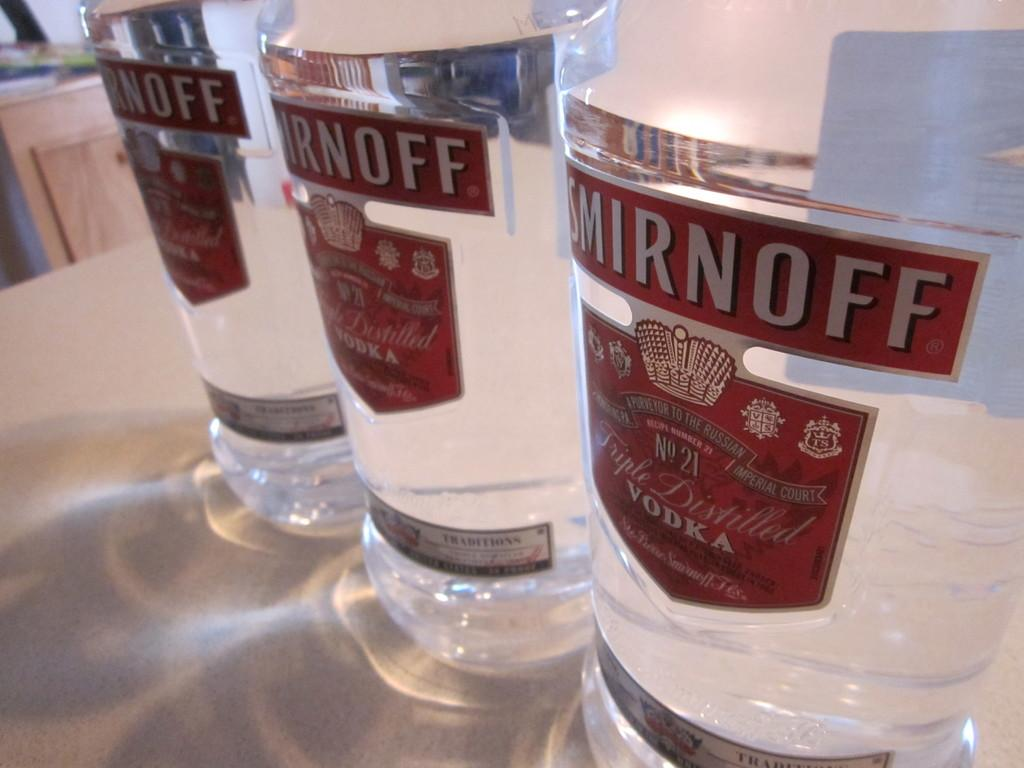Provide a one-sentence caption for the provided image. Three bottles of vodka from Smirnoff sitting on a table. 